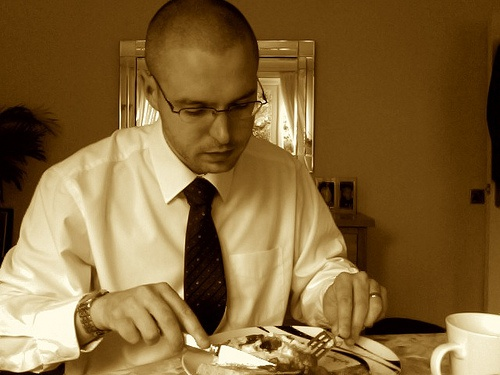Describe the objects in this image and their specific colors. I can see people in maroon, tan, olive, and black tones, dining table in maroon, olive, beige, and tan tones, tie in maroon, black, and olive tones, cup in maroon, beige, olive, and tan tones, and potted plant in maroon and black tones in this image. 